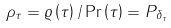<formula> <loc_0><loc_0><loc_500><loc_500>\rho _ { \tau } = \varrho \left ( \tau \right ) / \Pr \left ( \tau \right ) = P _ { \delta _ { \tau } }</formula> 